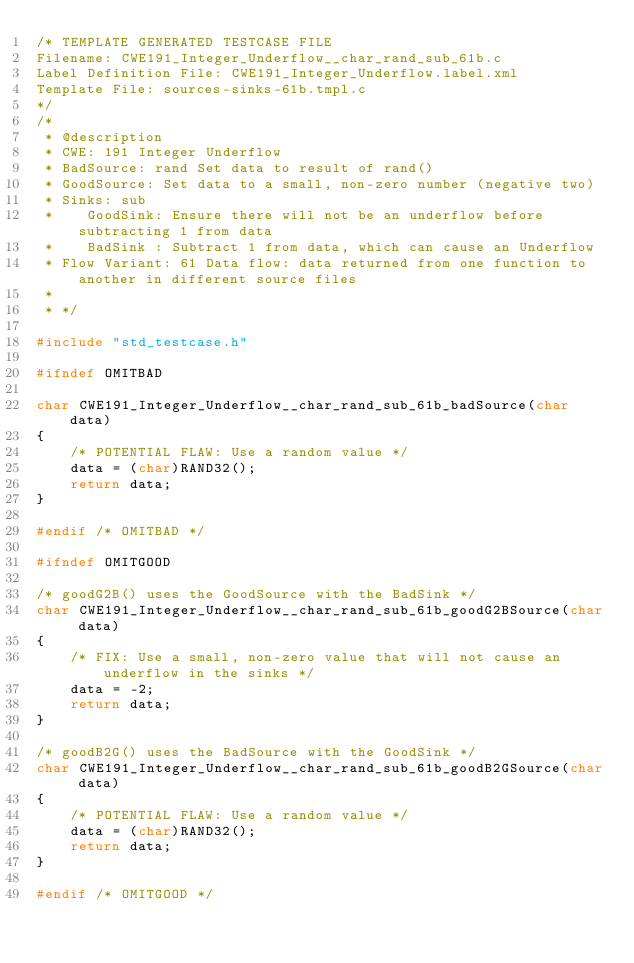<code> <loc_0><loc_0><loc_500><loc_500><_C_>/* TEMPLATE GENERATED TESTCASE FILE
Filename: CWE191_Integer_Underflow__char_rand_sub_61b.c
Label Definition File: CWE191_Integer_Underflow.label.xml
Template File: sources-sinks-61b.tmpl.c
*/
/*
 * @description
 * CWE: 191 Integer Underflow
 * BadSource: rand Set data to result of rand()
 * GoodSource: Set data to a small, non-zero number (negative two)
 * Sinks: sub
 *    GoodSink: Ensure there will not be an underflow before subtracting 1 from data
 *    BadSink : Subtract 1 from data, which can cause an Underflow
 * Flow Variant: 61 Data flow: data returned from one function to another in different source files
 *
 * */

#include "std_testcase.h"

#ifndef OMITBAD

char CWE191_Integer_Underflow__char_rand_sub_61b_badSource(char data)
{
    /* POTENTIAL FLAW: Use a random value */
    data = (char)RAND32();
    return data;
}

#endif /* OMITBAD */

#ifndef OMITGOOD

/* goodG2B() uses the GoodSource with the BadSink */
char CWE191_Integer_Underflow__char_rand_sub_61b_goodG2BSource(char data)
{
    /* FIX: Use a small, non-zero value that will not cause an underflow in the sinks */
    data = -2;
    return data;
}

/* goodB2G() uses the BadSource with the GoodSink */
char CWE191_Integer_Underflow__char_rand_sub_61b_goodB2GSource(char data)
{
    /* POTENTIAL FLAW: Use a random value */
    data = (char)RAND32();
    return data;
}

#endif /* OMITGOOD */
</code> 